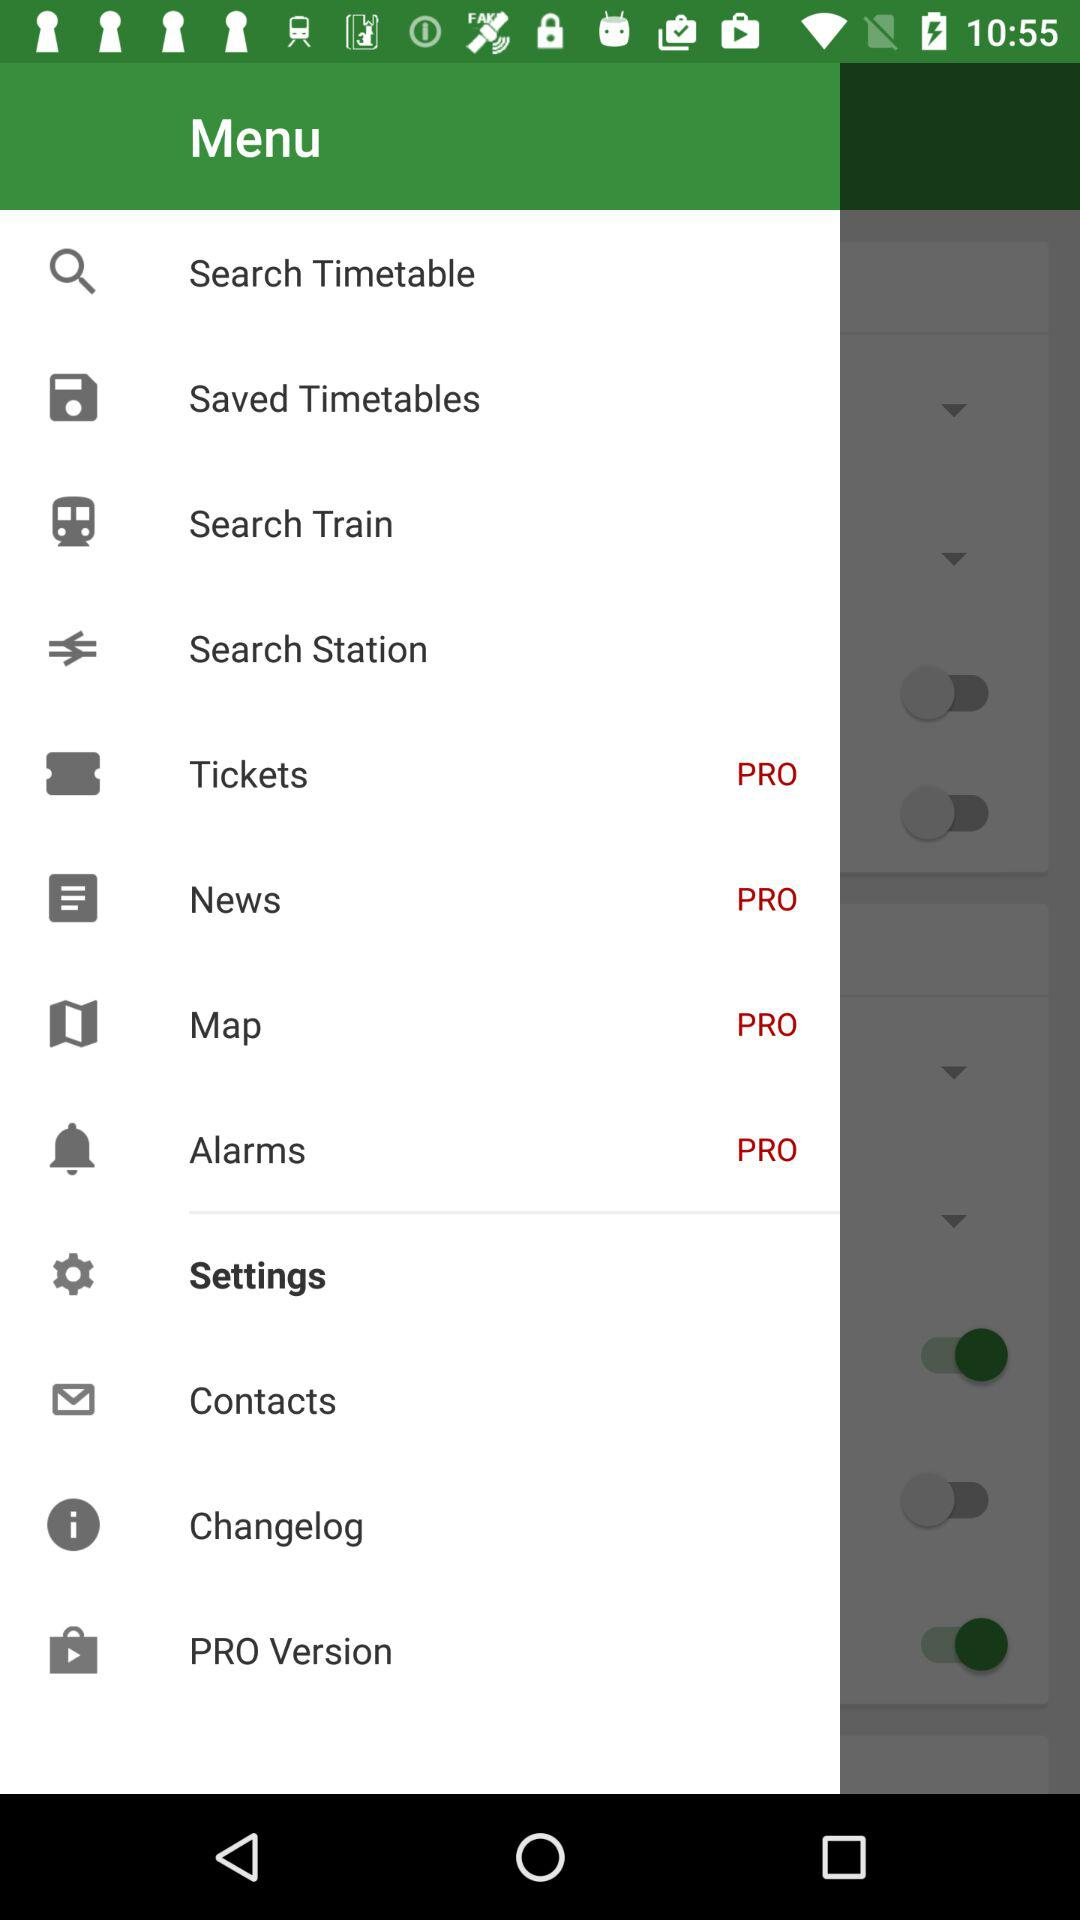Which item is selected in the menu? The selected item is "Settings". 